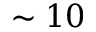<formula> <loc_0><loc_0><loc_500><loc_500>\sim 1 0</formula> 